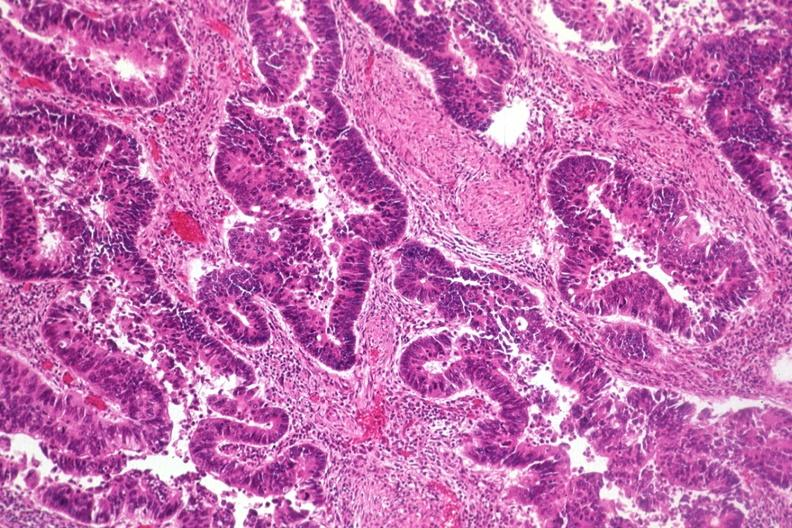s lymphangiomatosis present?
Answer the question using a single word or phrase. No 